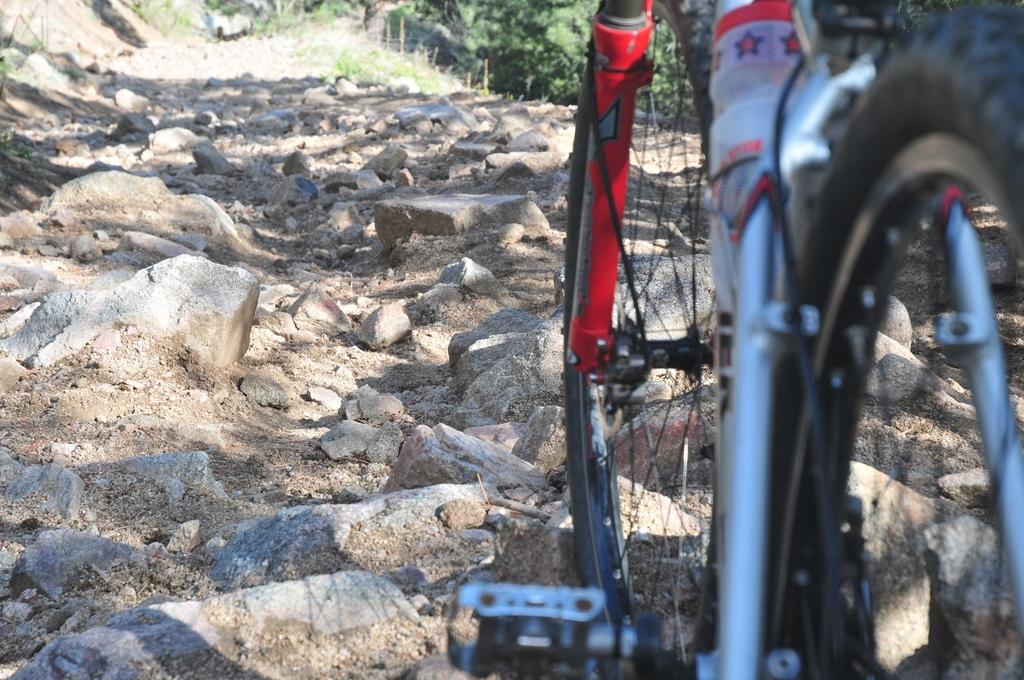In one or two sentences, can you explain what this image depicts? In this image we can see cycle , there are some rocks and trees. 